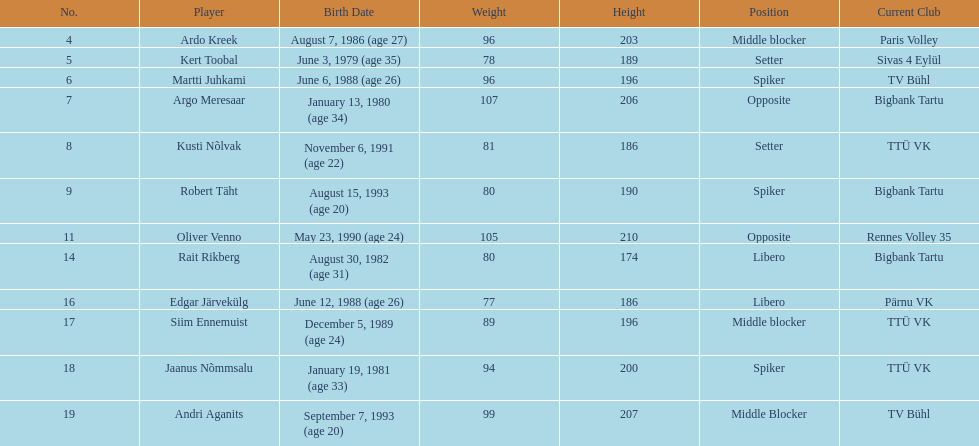What is the overall count of players from france? 2. 